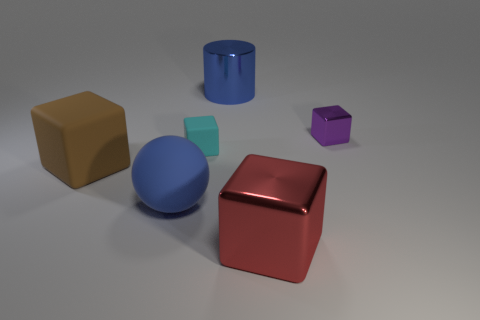What size is the ball that is the same color as the large shiny cylinder?
Make the answer very short. Large. What number of things are either blue metallic balls or tiny things?
Your answer should be compact. 2. There is a large thing that is both to the right of the cyan block and in front of the small purple shiny cube; what is its shape?
Offer a terse response. Cube. There is a large brown thing; does it have the same shape as the tiny object left of the big metal cube?
Your response must be concise. Yes. Are there any big brown objects to the left of the purple metallic object?
Make the answer very short. Yes. What is the material of the ball that is the same color as the metallic cylinder?
Your answer should be compact. Rubber. How many balls are large brown matte objects or red shiny things?
Provide a short and direct response. 0. Is the shape of the tiny metallic object the same as the large blue rubber thing?
Your answer should be compact. No. What size is the metal cube that is behind the red thing?
Offer a terse response. Small. Are there any matte things of the same color as the cylinder?
Your response must be concise. Yes. 